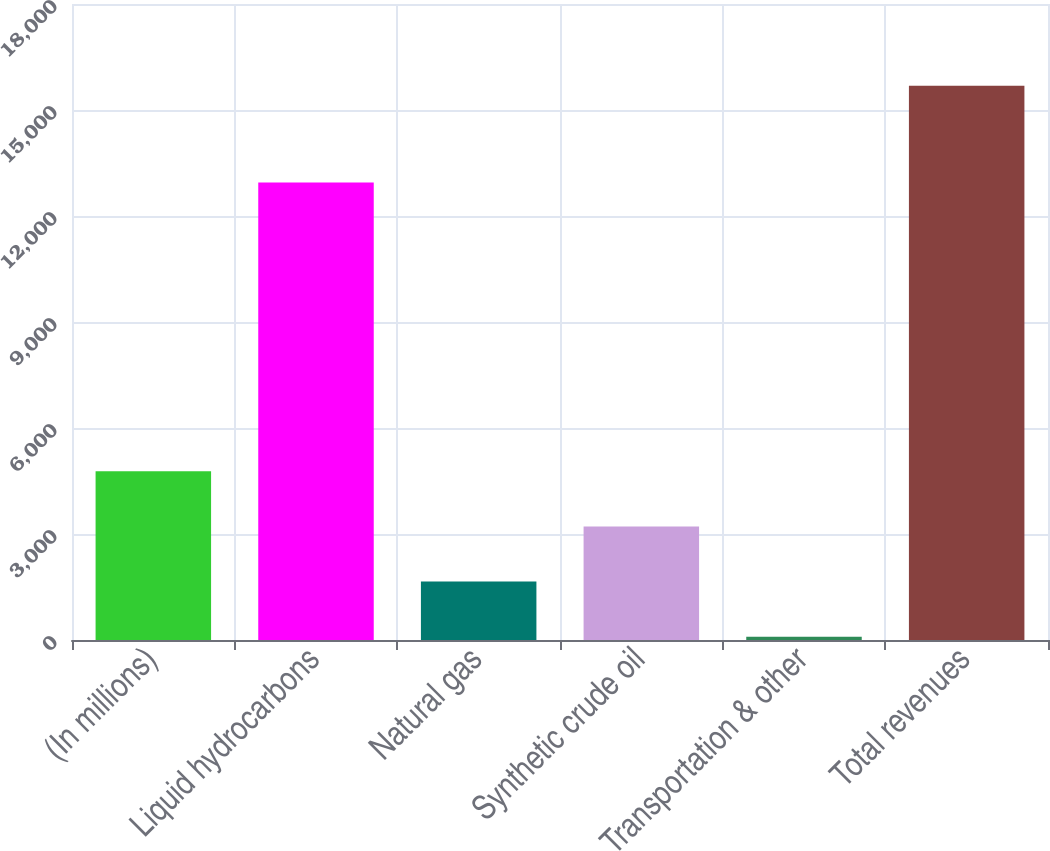Convert chart. <chart><loc_0><loc_0><loc_500><loc_500><bar_chart><fcel>(In millions)<fcel>Liquid hydrocarbons<fcel>Natural gas<fcel>Synthetic crude oil<fcel>Transportation & other<fcel>Total revenues<nl><fcel>4772.9<fcel>12945<fcel>1654.3<fcel>3213.6<fcel>95<fcel>15688<nl></chart> 